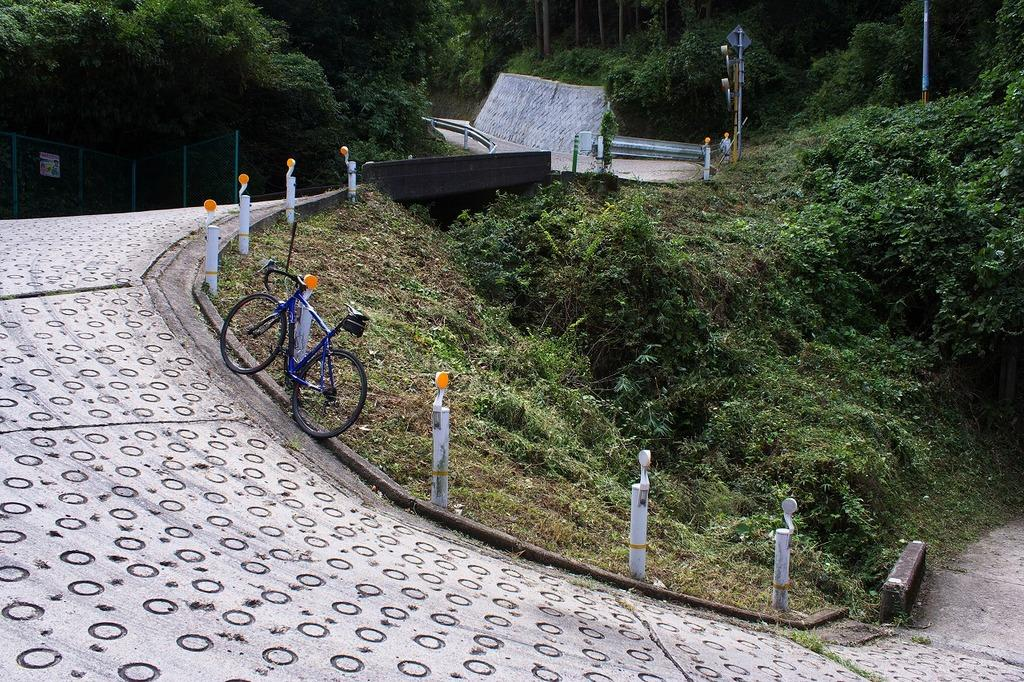What is located in the center of the image? There are trees, plants, poles, a cycle, a fence, and a few other objects in the center of the image. Can you describe the trees in the image? The trees are located in the center of the image. What type of plants are present in the image? There are plants in the center of the image. What is the purpose of the poles in the image? The purpose of the poles in the image is not specified, but they are located in the center of the image. What is the cycle used for in the image? The cycle is located in the center of the image, but its purpose is not specified. What is the fence used for in the image? The fence is located in the center of the image, but its purpose is not specified. How many planes are flying in the image? There are no planes visible in the image. What type of trick is being performed with the trees in the image? There is no trick being performed with the trees in the image; they are simply located in the center of the image. 